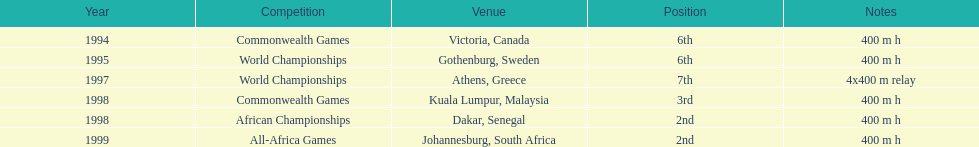Where was the next venue after athens, greece? Kuala Lumpur, Malaysia. 